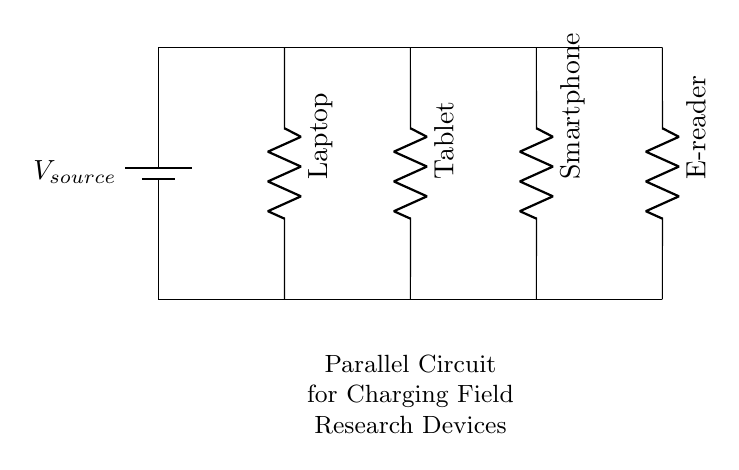What is the total number of devices in the circuit? The circuit diagram shows four devices connected in parallel: a laptop, a tablet, a smartphone, and an e-reader. Counting these devices gives a total of four.
Answer: Four What type of circuit is this? The components are connected so that there are multiple paths for current to flow, indicating that this is a parallel circuit.
Answer: Parallel What label is assigned to the power source? The diagram clearly indicates the power source with the label V source, which designates the voltage supply for the circuit.
Answer: V source Which device is placed at the second position in the circuit? By looking at the vertical alignment of the devices, the second device from the left is the tablet, which is the one connected to the second branch of the parallel circuit.
Answer: Tablet What is the arrangement of the devices in the circuit? In a parallel configuration, the devices are arranged side by side, each connected to the same voltage source but independently of one another. This means each device gets the same voltage from the source.
Answer: Side by side How does the voltage across each device compare? In a parallel circuit, each device experiences the same voltage as the power source, so the voltage across each device will be equal to the voltage of the power source, V source.
Answer: Equal to V source How many resistors are shown in the circuit? The circuit diagram depicts four resistors, one for each device. Each device has its own resistor, representing the load each device presents to the circuit.
Answer: Four 